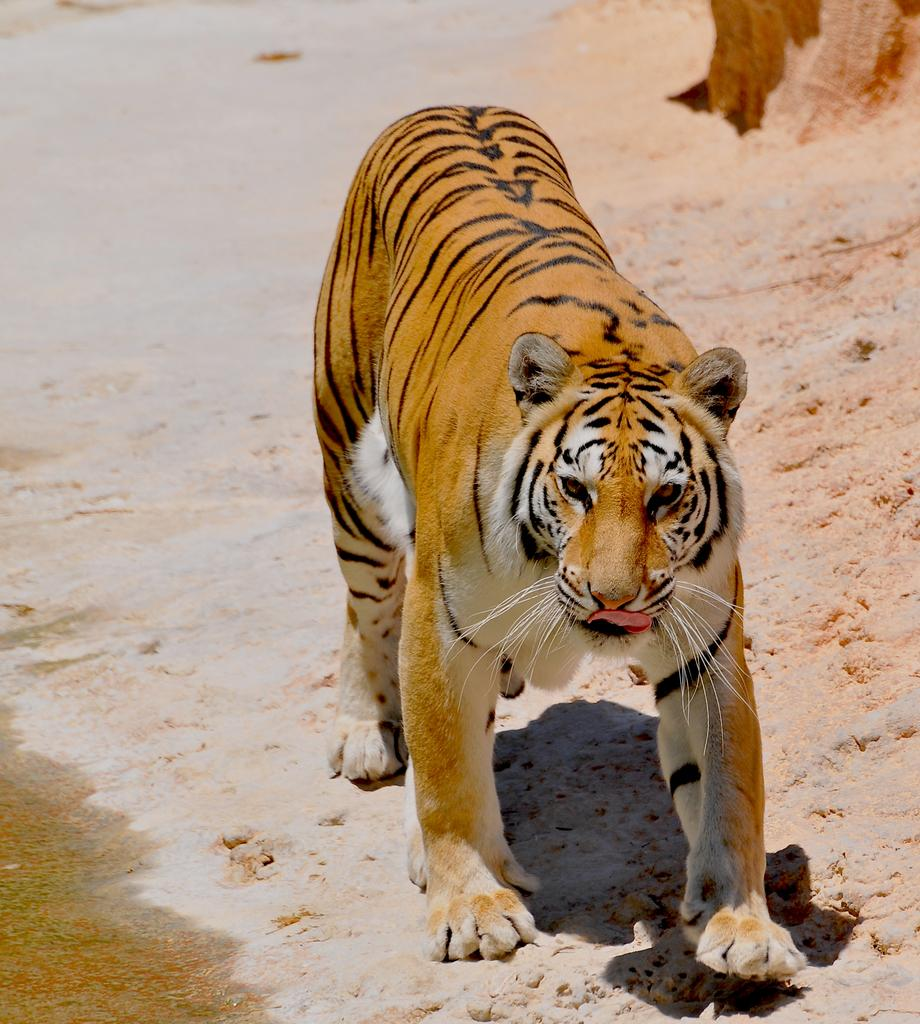What animal is present in the image? There is a tiger in the image. What is the tiger doing in the image? The tiger is walking on the ground in the image. What can be seen in the background of the image? There is an open land visible in the background of the image. What is located on the left side of the image? There is water visible on the left side of the image. Where is the basin located in the image? There is no basin present in the image. What type of cover is protecting the tiger in the image? The tiger is not protected by any cover in the image; it is walking on the ground. 